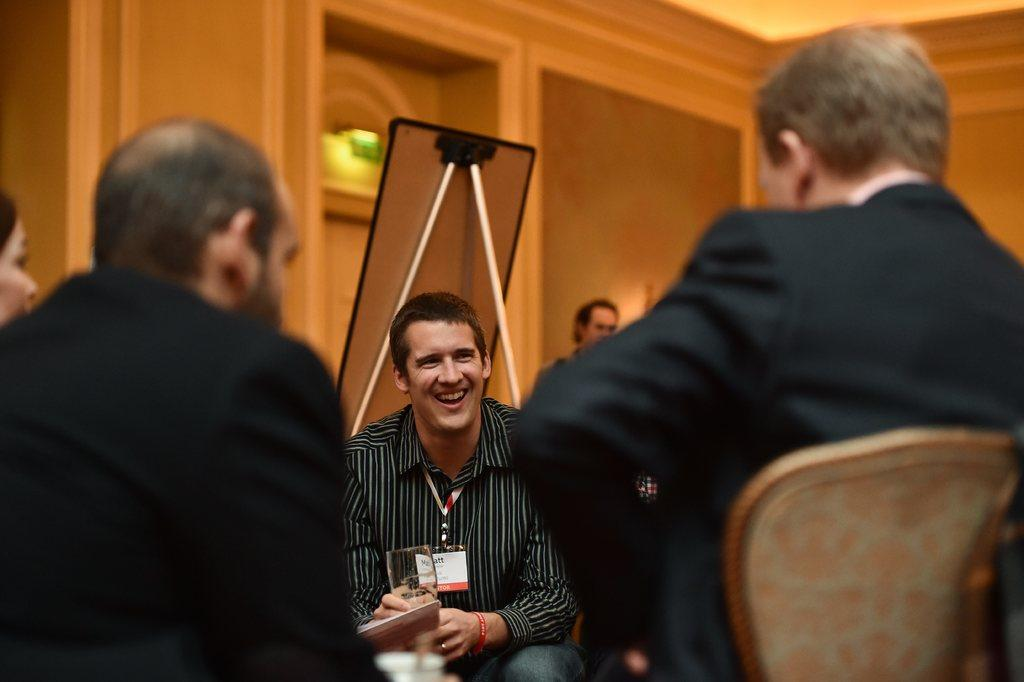What are the people in the image doing? The people in the image are sitting on chairs. What is the man holding in his hand? The man is holding a wine glass in his hand. Can you describe the man's attire? The man is wearing an ID card. What is the position of the person standing behind the man with the wine glass? There is a person standing behind the man with the wine glass. What type of coast can be seen in the image? There is no coast present in the image. How many hands does the man have on his head in the image? The man does not have any hands on his head in the image. 